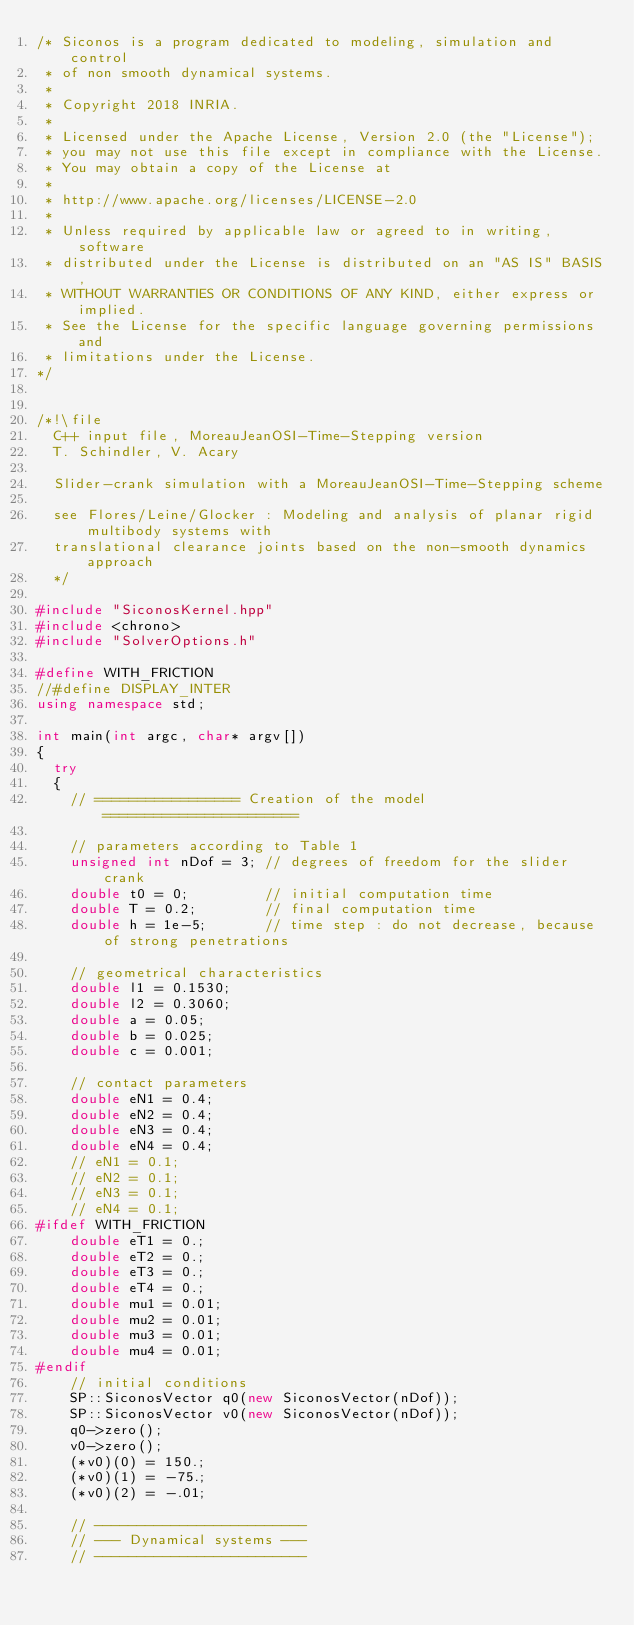<code> <loc_0><loc_0><loc_500><loc_500><_C++_>/* Siconos is a program dedicated to modeling, simulation and control
 * of non smooth dynamical systems.
 *
 * Copyright 2018 INRIA.
 *
 * Licensed under the Apache License, Version 2.0 (the "License");
 * you may not use this file except in compliance with the License.
 * You may obtain a copy of the License at
 *
 * http://www.apache.org/licenses/LICENSE-2.0
 *
 * Unless required by applicable law or agreed to in writing, software
 * distributed under the License is distributed on an "AS IS" BASIS,
 * WITHOUT WARRANTIES OR CONDITIONS OF ANY KIND, either express or implied.
 * See the License for the specific language governing permissions and
 * limitations under the License.
*/


/*!\file
  C++ input file, MoreauJeanOSI-Time-Stepping version
  T. Schindler, V. Acary

  Slider-crank simulation with a MoreauJeanOSI-Time-Stepping scheme

  see Flores/Leine/Glocker : Modeling and analysis of planar rigid multibody systems with
  translational clearance joints based on the non-smooth dynamics approach
  */

#include "SiconosKernel.hpp"
#include <chrono>
#include "SolverOptions.h"

#define WITH_FRICTION
//#define DISPLAY_INTER
using namespace std;

int main(int argc, char* argv[])
{
  try
  {
    // ================= Creation of the model =======================

    // parameters according to Table 1
    unsigned int nDof = 3; // degrees of freedom for the slider crank
    double t0 = 0;         // initial computation time
    double T = 0.2;        // final computation time
    double h = 1e-5;       // time step : do not decrease, because of strong penetrations

    // geometrical characteristics
    double l1 = 0.1530;
    double l2 = 0.3060;
    double a = 0.05;
    double b = 0.025;
    double c = 0.001;

    // contact parameters
    double eN1 = 0.4;
    double eN2 = 0.4;
    double eN3 = 0.4;
    double eN4 = 0.4;
    // eN1 = 0.1;
    // eN2 = 0.1;
    // eN3 = 0.1;
    // eN4 = 0.1;
#ifdef WITH_FRICTION
    double eT1 = 0.;
    double eT2 = 0.;
    double eT3 = 0.;
    double eT4 = 0.;
    double mu1 = 0.01;
    double mu2 = 0.01;
    double mu3 = 0.01;
    double mu4 = 0.01;
#endif
    // initial conditions
    SP::SiconosVector q0(new SiconosVector(nDof));
    SP::SiconosVector v0(new SiconosVector(nDof));
    q0->zero();
    v0->zero();
    (*v0)(0) = 150.;
    (*v0)(1) = -75.;
    (*v0)(2) = -.01;

    // -------------------------
    // --- Dynamical systems ---
    // -------------------------</code> 